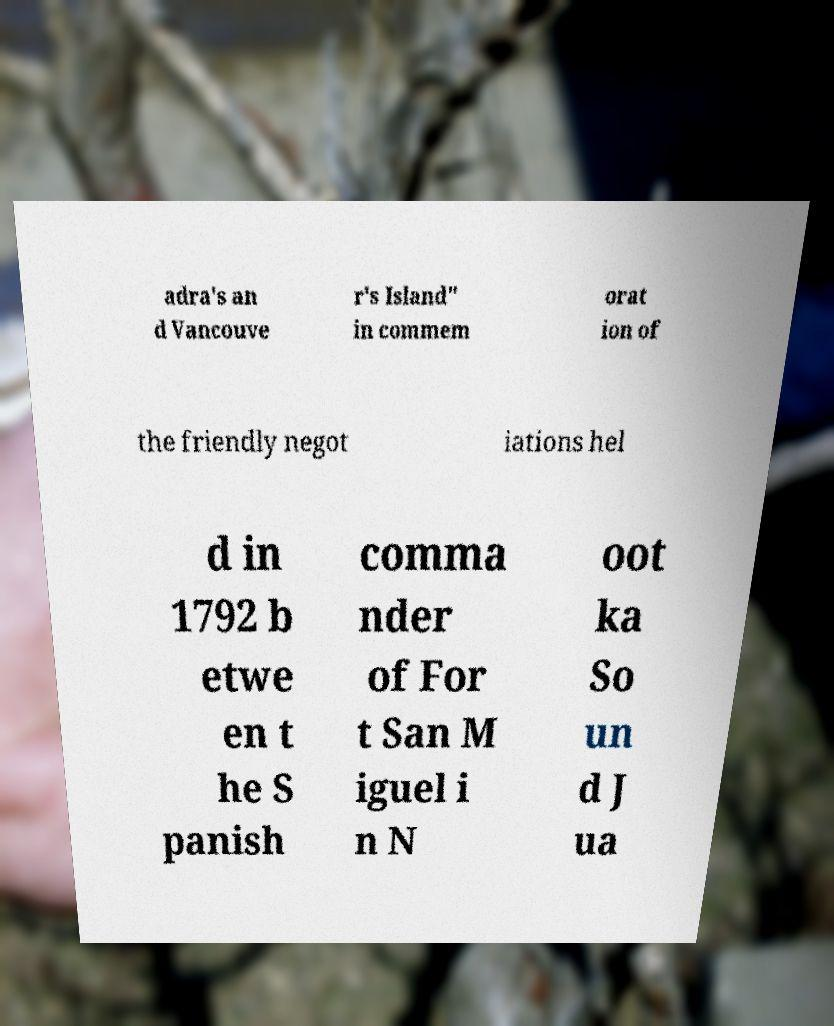Please read and relay the text visible in this image. What does it say? adra's an d Vancouve r's Island" in commem orat ion of the friendly negot iations hel d in 1792 b etwe en t he S panish comma nder of For t San M iguel i n N oot ka So un d J ua 